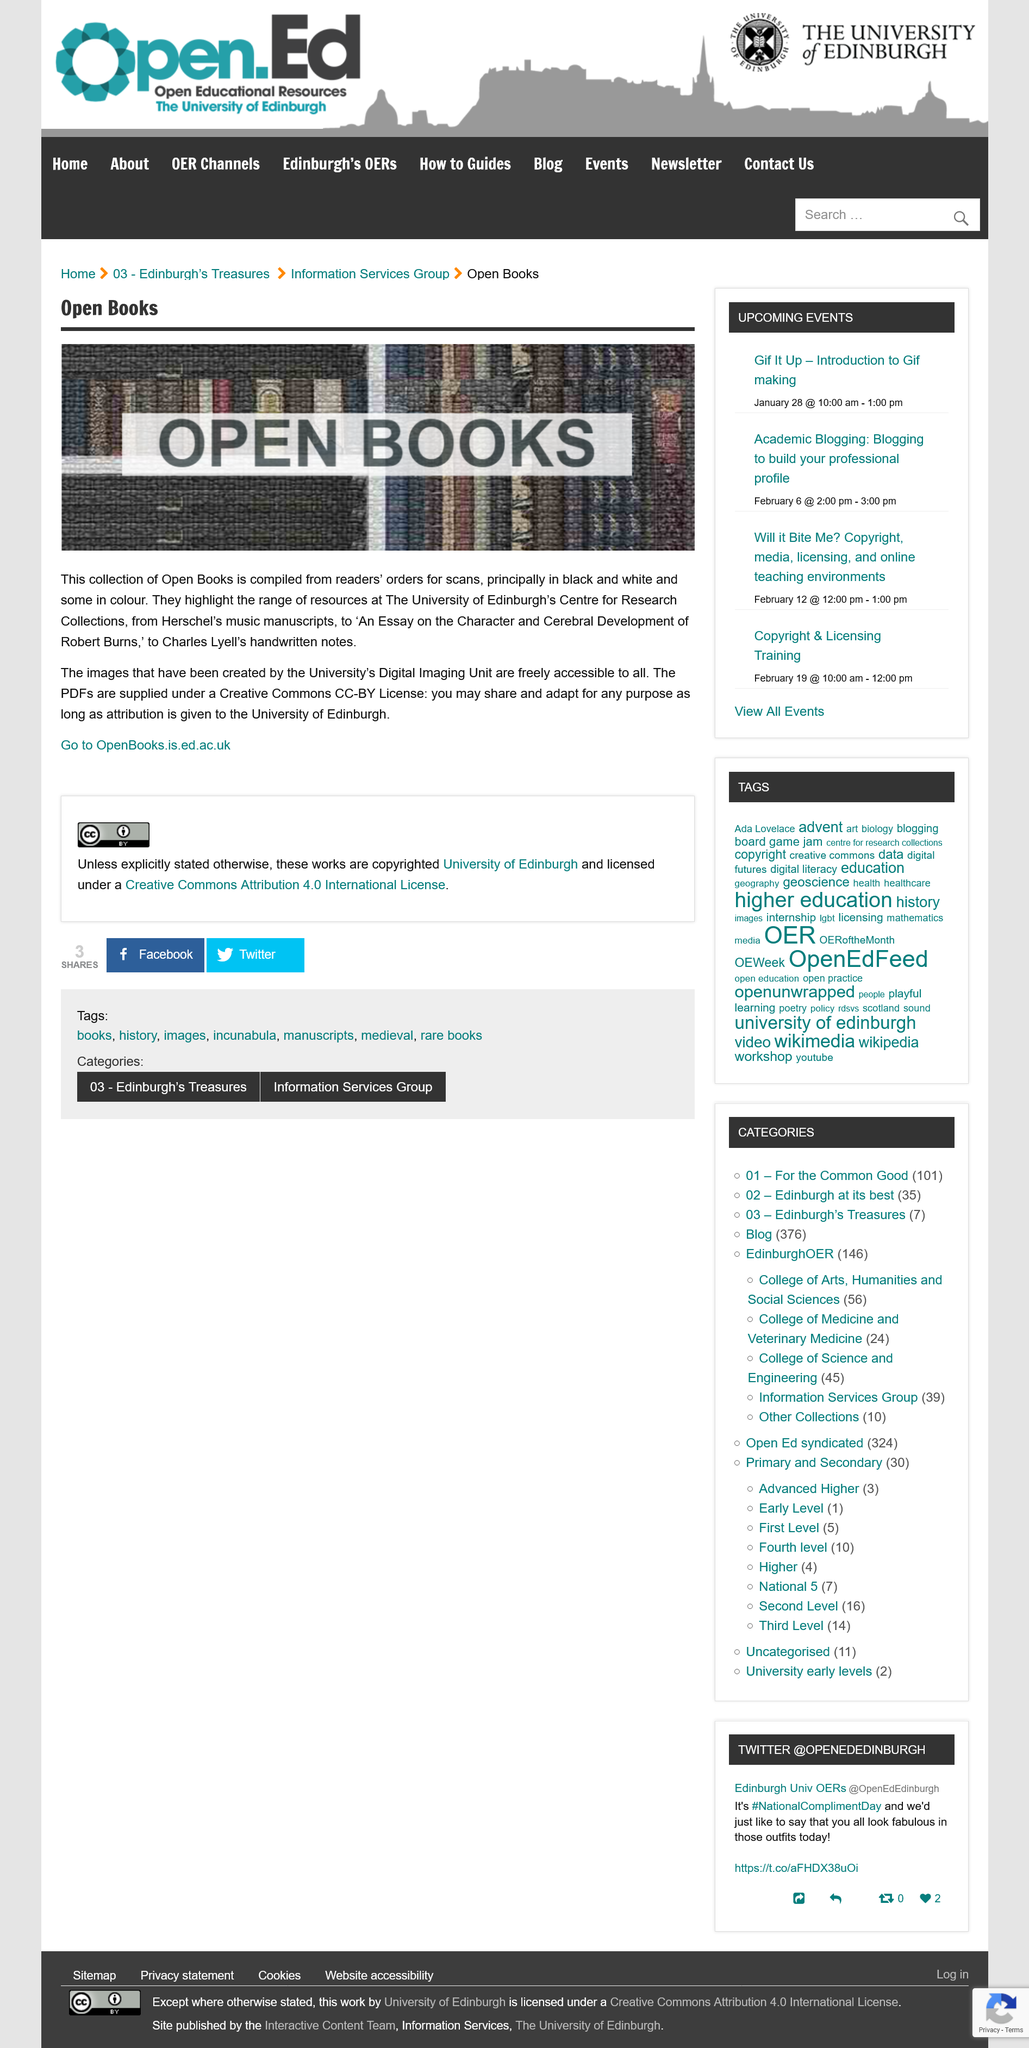Give some essential details in this illustration. Some of the scans are in color. Yes, the collection consists of scans that were compiled based on readers' orders and are licensed under a Creative Commons CC-BY license. The handwritten notes were created by Charles Lyell. 